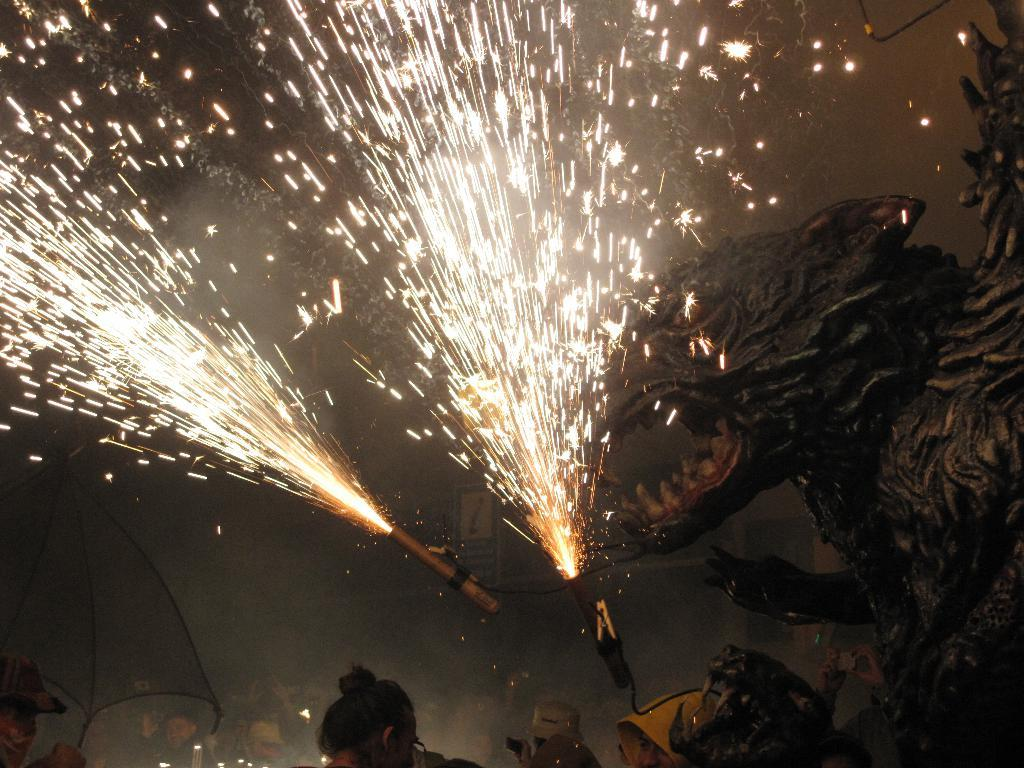What is happening to the two objects in the image? Fire is coming from two objects in the image. What can be seen on the right side of the image? There is a sculpture on the right side of the image. Who or what is at the bottom of the image? There is a group of persons at the bottom of the image. What else can be found at the bottom of the image? There are a few objects at the bottom of the image. Where are the kittens playing in the image? There are no kittens present in the image. What type of stem is supporting the sculpture in the image? The image does not show any stems supporting the sculpture; it is standing on its own. 